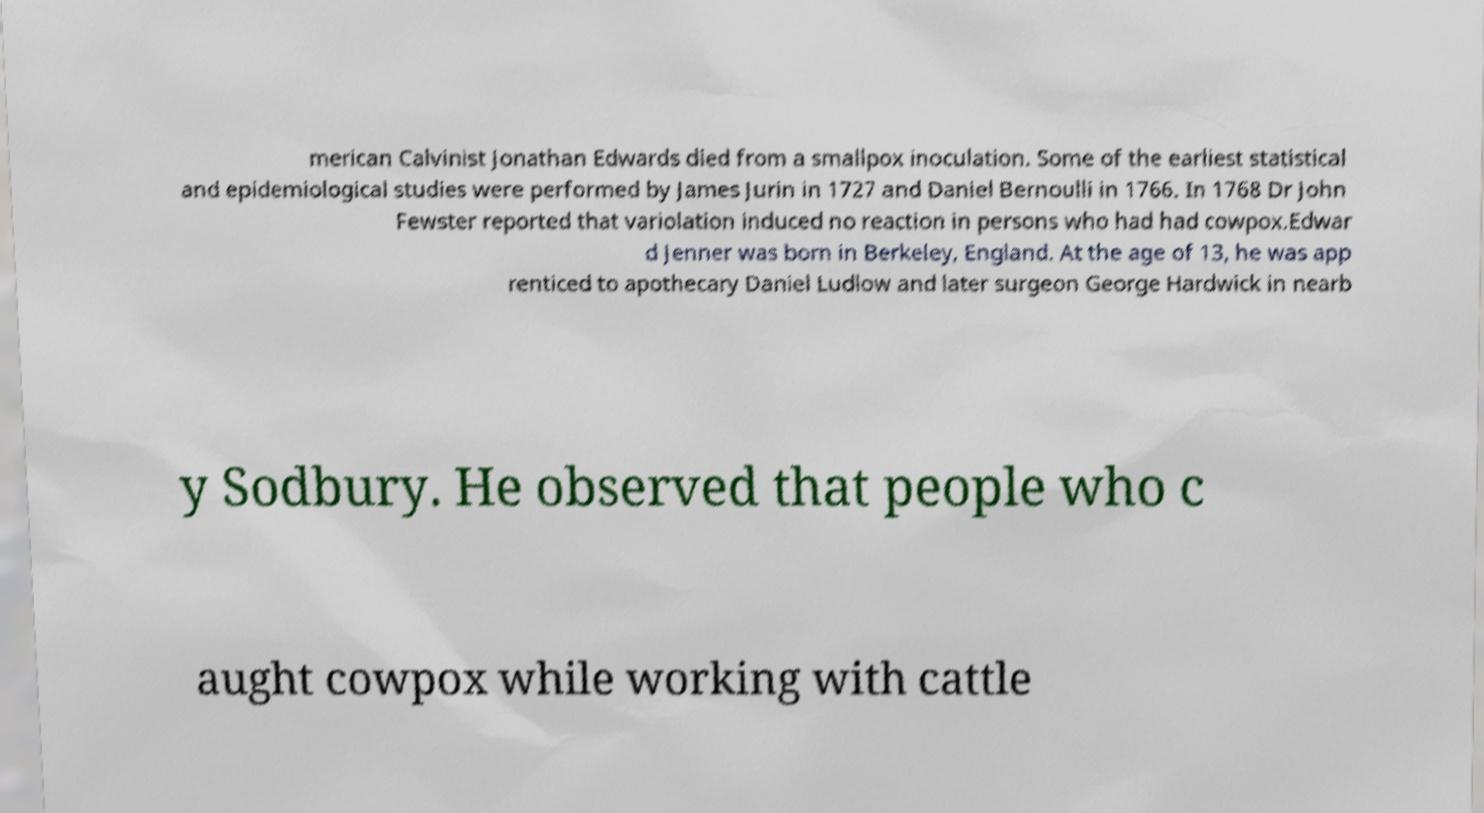Could you assist in decoding the text presented in this image and type it out clearly? merican Calvinist Jonathan Edwards died from a smallpox inoculation. Some of the earliest statistical and epidemiological studies were performed by James Jurin in 1727 and Daniel Bernoulli in 1766. In 1768 Dr John Fewster reported that variolation induced no reaction in persons who had had cowpox.Edwar d Jenner was born in Berkeley, England. At the age of 13, he was app renticed to apothecary Daniel Ludlow and later surgeon George Hardwick in nearb y Sodbury. He observed that people who c aught cowpox while working with cattle 